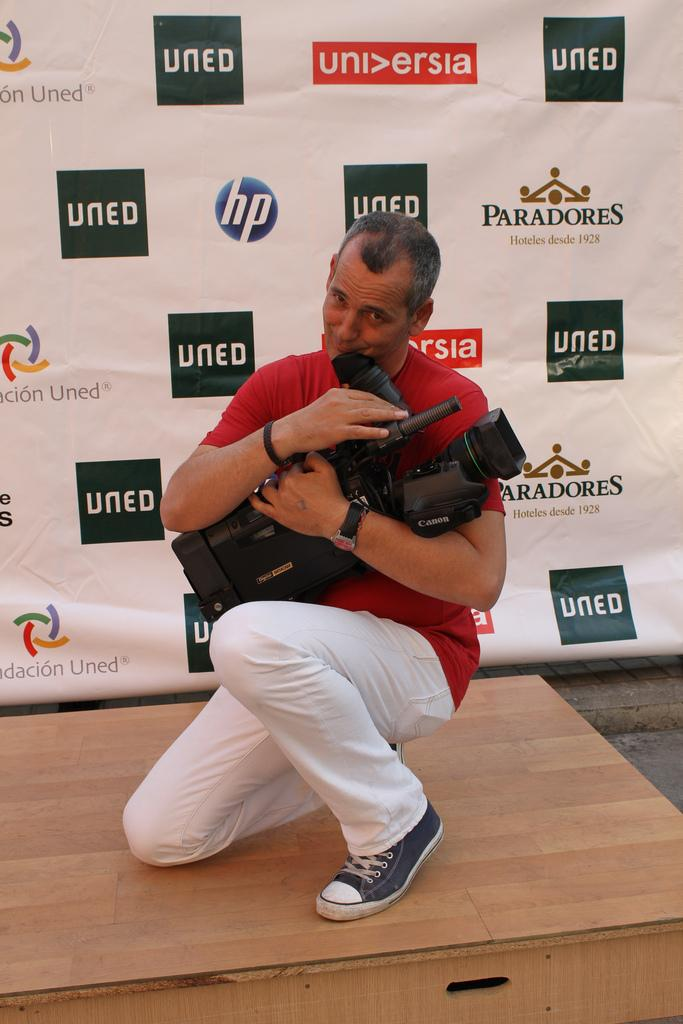<image>
Give a short and clear explanation of the subsequent image. A man with a video camera kneeling in front of a backdrop that says hp, Paradores, UNED, and UNI>ERSIA. 